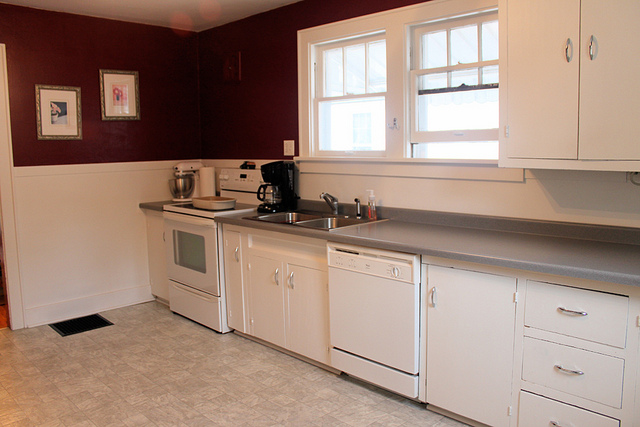Are there any objects on the countertop near the sink? Yes, beside the sink on the countertop, there is a mixer or kitchen tool and a soap dispenser, showcasing a functional and organized space. 